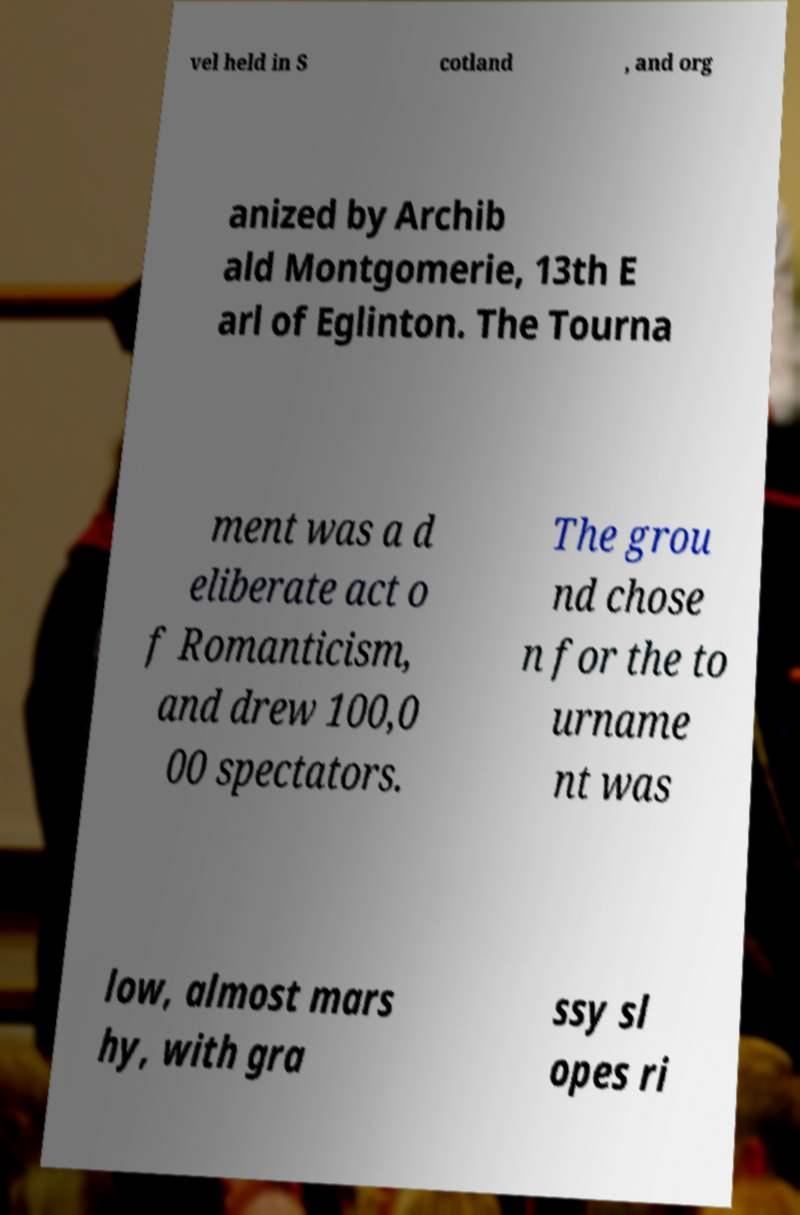What messages or text are displayed in this image? I need them in a readable, typed format. vel held in S cotland , and org anized by Archib ald Montgomerie, 13th E arl of Eglinton. The Tourna ment was a d eliberate act o f Romanticism, and drew 100,0 00 spectators. The grou nd chose n for the to urname nt was low, almost mars hy, with gra ssy sl opes ri 